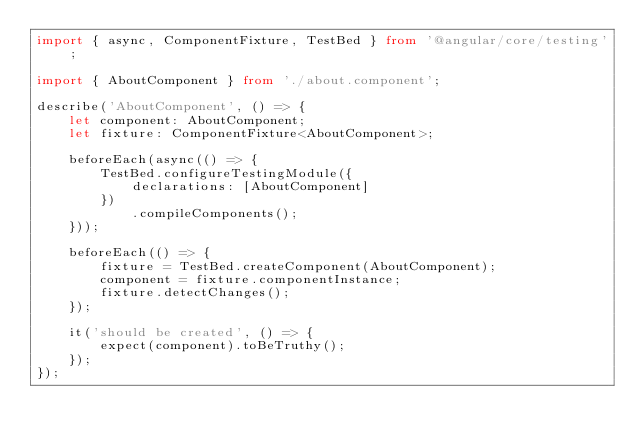<code> <loc_0><loc_0><loc_500><loc_500><_TypeScript_>import { async, ComponentFixture, TestBed } from '@angular/core/testing';

import { AboutComponent } from './about.component';

describe('AboutComponent', () => {
    let component: AboutComponent;
    let fixture: ComponentFixture<AboutComponent>;

    beforeEach(async(() => {
        TestBed.configureTestingModule({
            declarations: [AboutComponent]
        })
            .compileComponents();
    }));

    beforeEach(() => {
        fixture = TestBed.createComponent(AboutComponent);
        component = fixture.componentInstance;
        fixture.detectChanges();
    });

    it('should be created', () => {
        expect(component).toBeTruthy();
    });
});
</code> 